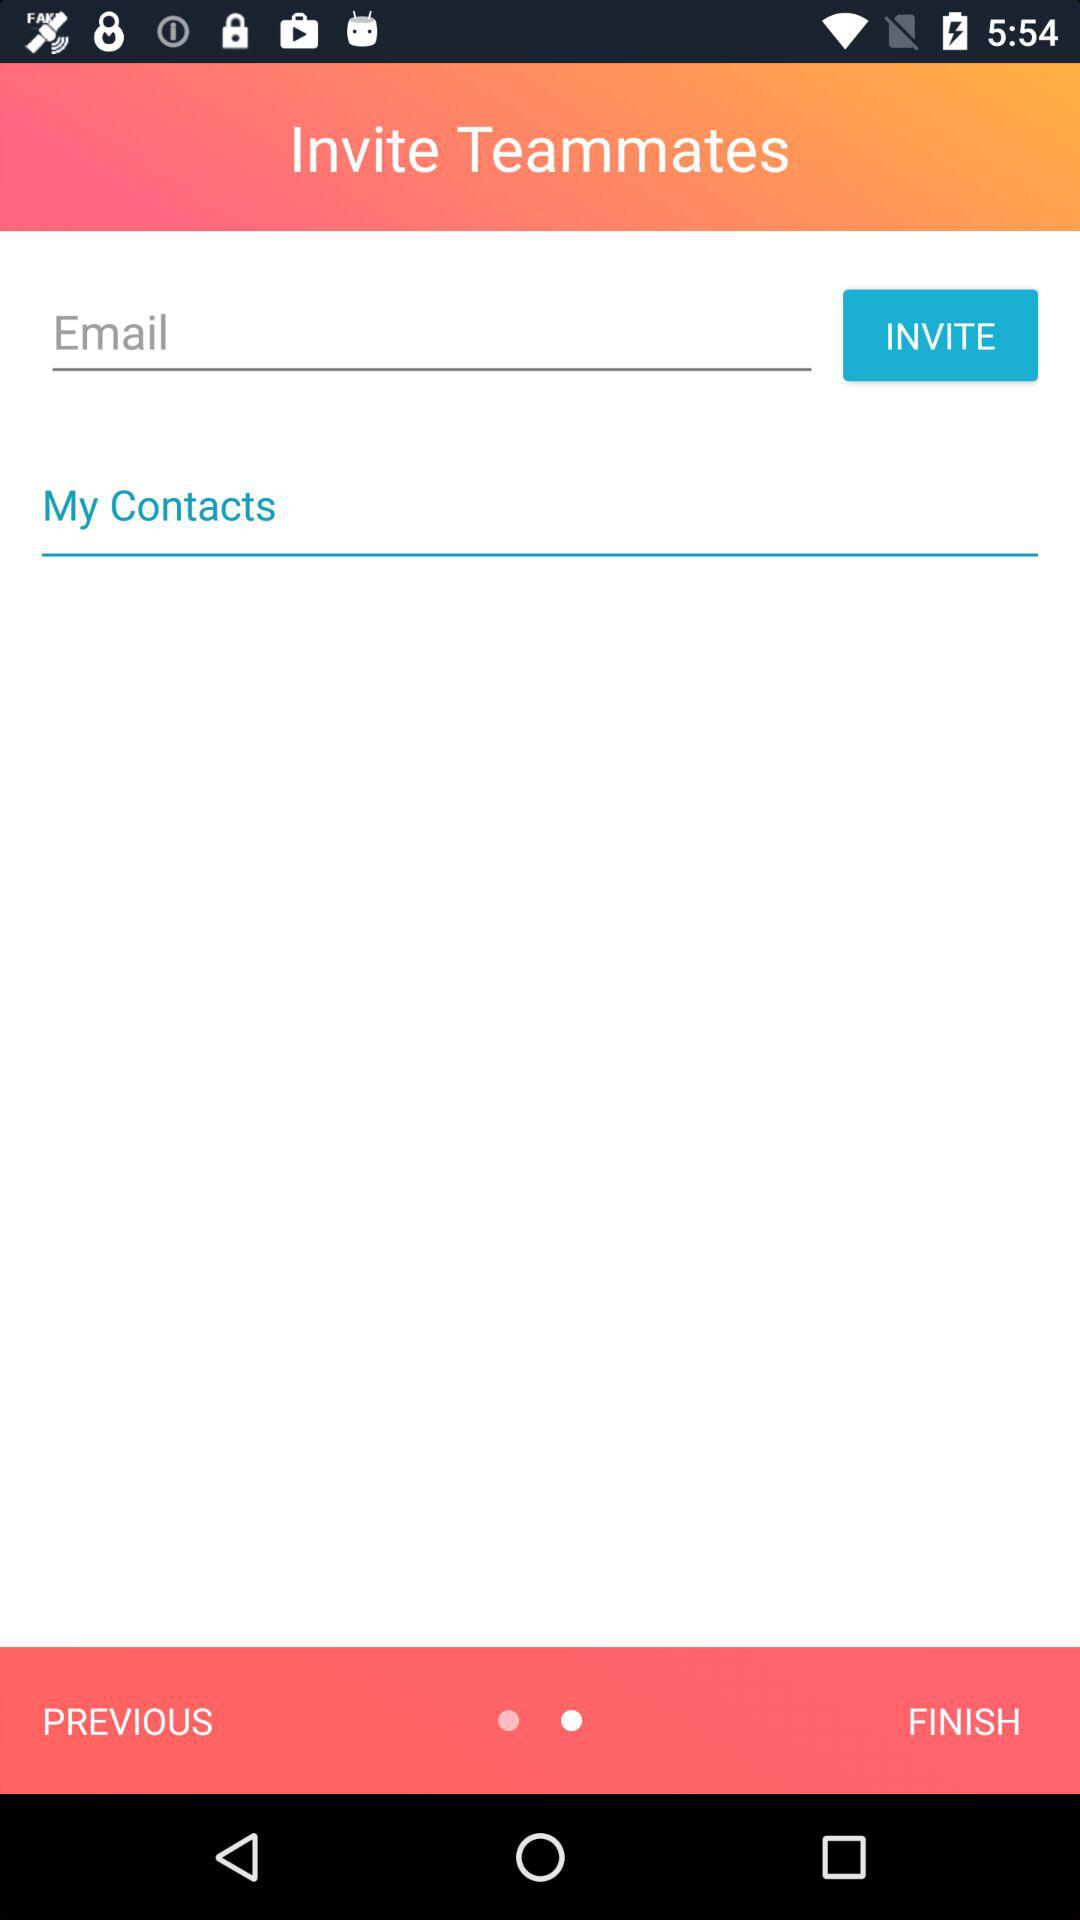What are the requirements for inviting teammates? The requirement for inviting teammates is email. 